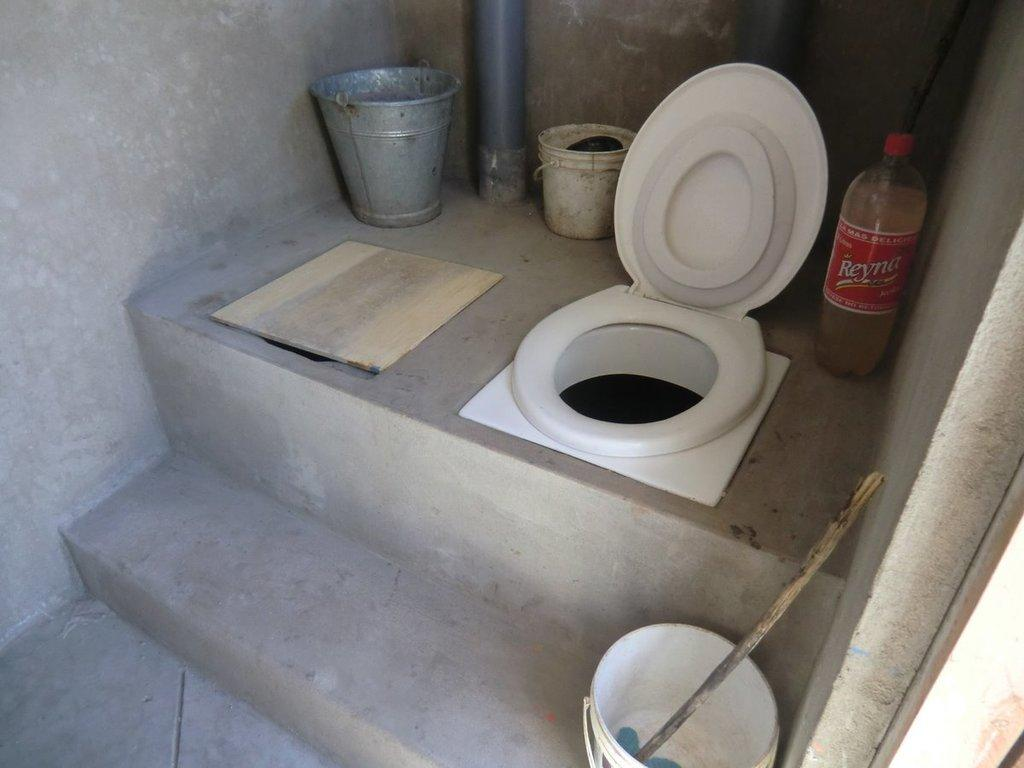What type of fixture is present in the image? There is a toilet in the image. What other objects can be seen in the image? There are buckets and a wooden board in the image. Is there any container visible in the image? Yes, there is a bottle in the image. What type of disgusting pocket is present in the image? There is no pocket, disgusting or otherwise, present in the image. 